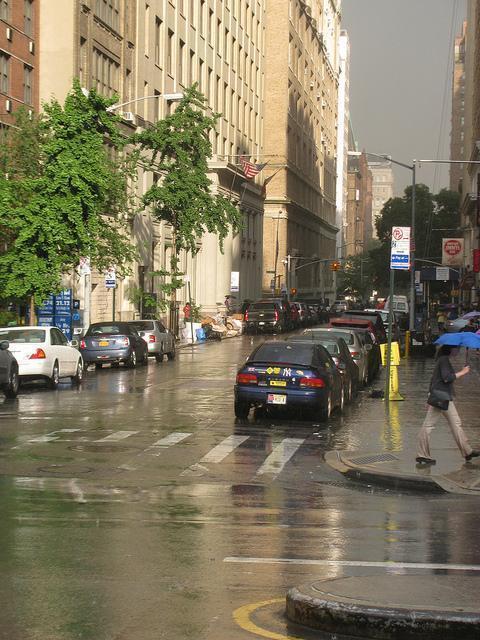How many cars are there?
Give a very brief answer. 4. How many non-chocolate donuts are in the picture?
Give a very brief answer. 0. 